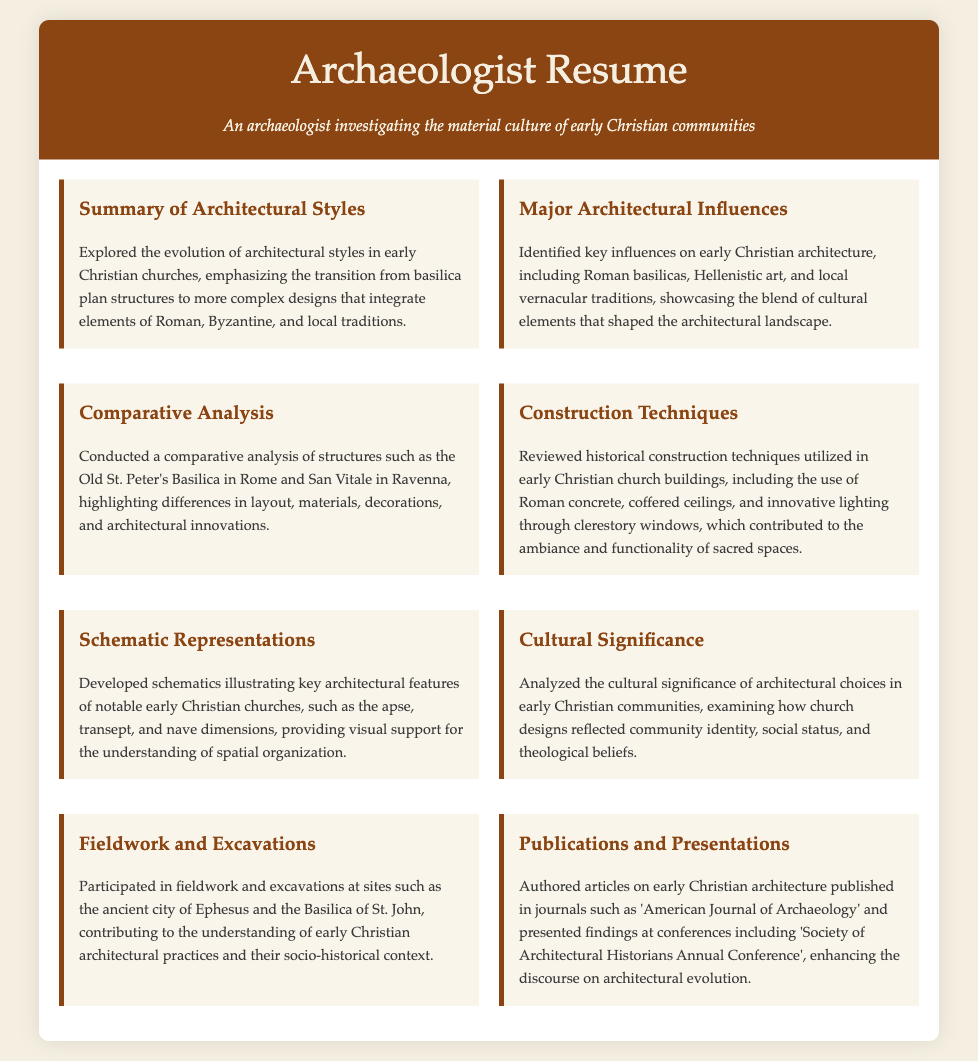What is the title of the resume? The title of the resume is prominently displayed at the top of the document.
Answer: Archaeologist Resume What major architectural influences are identified? The resume lists specific influences that shaped early Christian architecture.
Answer: Roman basilicas, Hellenistic art, and local vernacular traditions Which buildings are compared in the comparative analysis section? The specific buildings mentioned in the analysis section illustrate the focus of the study.
Answer: Old St. Peter's Basilica and San Vitale What construction techniques are reviewed? The resume summarizes particular construction methodologies used in early Christian churches.
Answer: Roman concrete, coffered ceilings, and innovative lighting What is one purpose of the schematic representations developed? The purpose of the schematics is detailed in the document, focusing on a specific aspect.
Answer: Understanding of spatial organization What sites were mentioned in the fieldwork and excavations section? The resume provides names of sites where archaeological work took place.
Answer: Ancient city of Ephesus and Basilica of St. John How did the architectural choices reflect early Christian communities? The resume discusses the implications of architectural designs on community identity.
Answer: Community identity, social status, and theological beliefs What type of publications did the individual author? The resume notes the nature of the written works produced.
Answer: Articles on early Christian architecture 